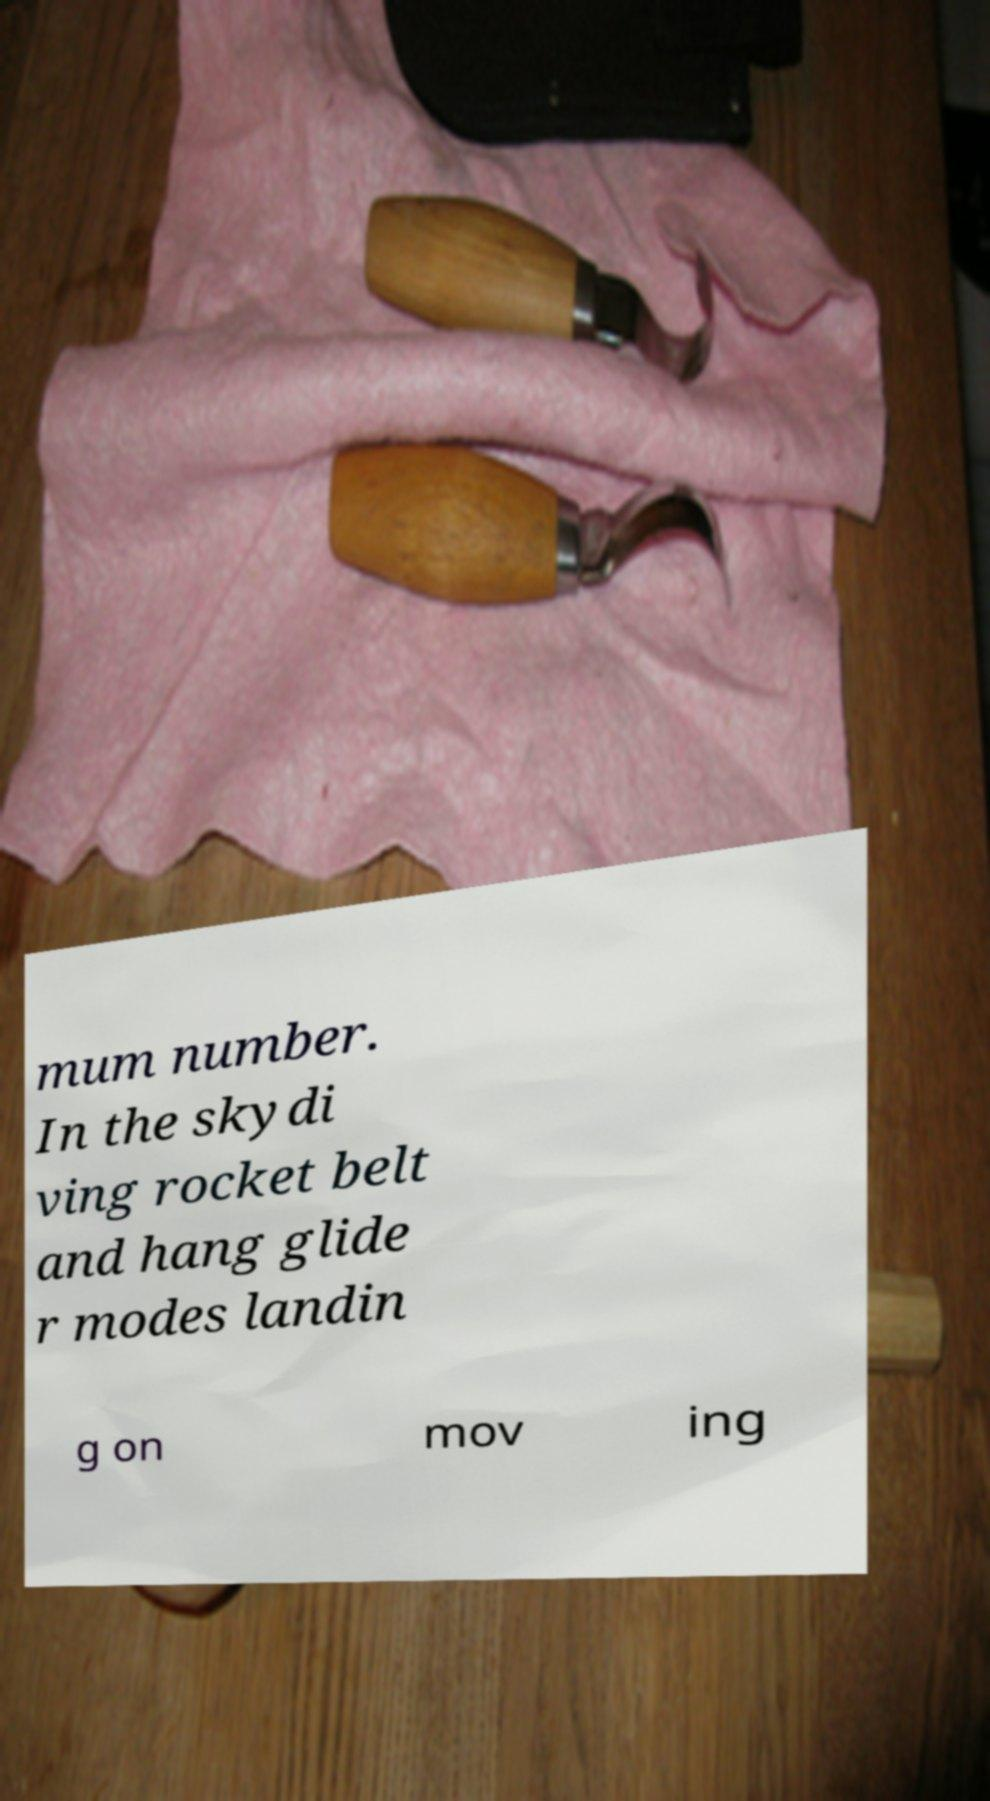For documentation purposes, I need the text within this image transcribed. Could you provide that? mum number. In the skydi ving rocket belt and hang glide r modes landin g on mov ing 